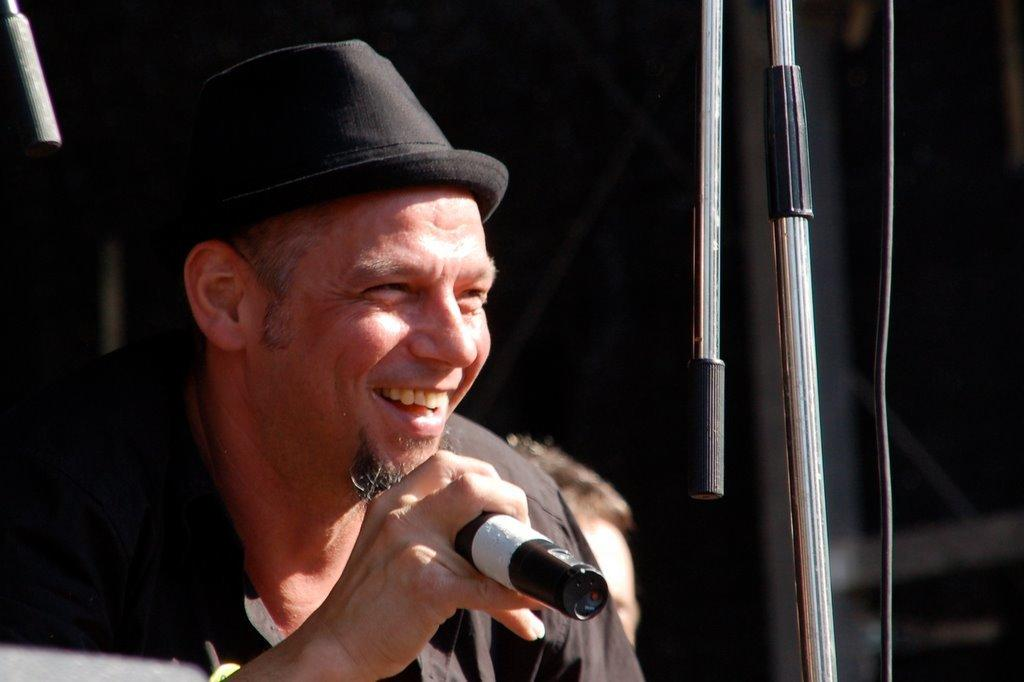What is the man in the image doing? The man is smiling in the image. What is the man holding in his right hand? The man is holding a microphone in his right hand. What type of headwear is the man wearing? The man is wearing a hat. Can you describe the person behind the man? There is a person behind the man, but no specific details are provided about them. What type of basin is visible in the image? There is no basin present in the image. How does the man tie the knot in the image? The man is not tying a knot in the image; he is holding a microphone. 